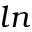Convert formula to latex. <formula><loc_0><loc_0><loc_500><loc_500>\ln</formula> 